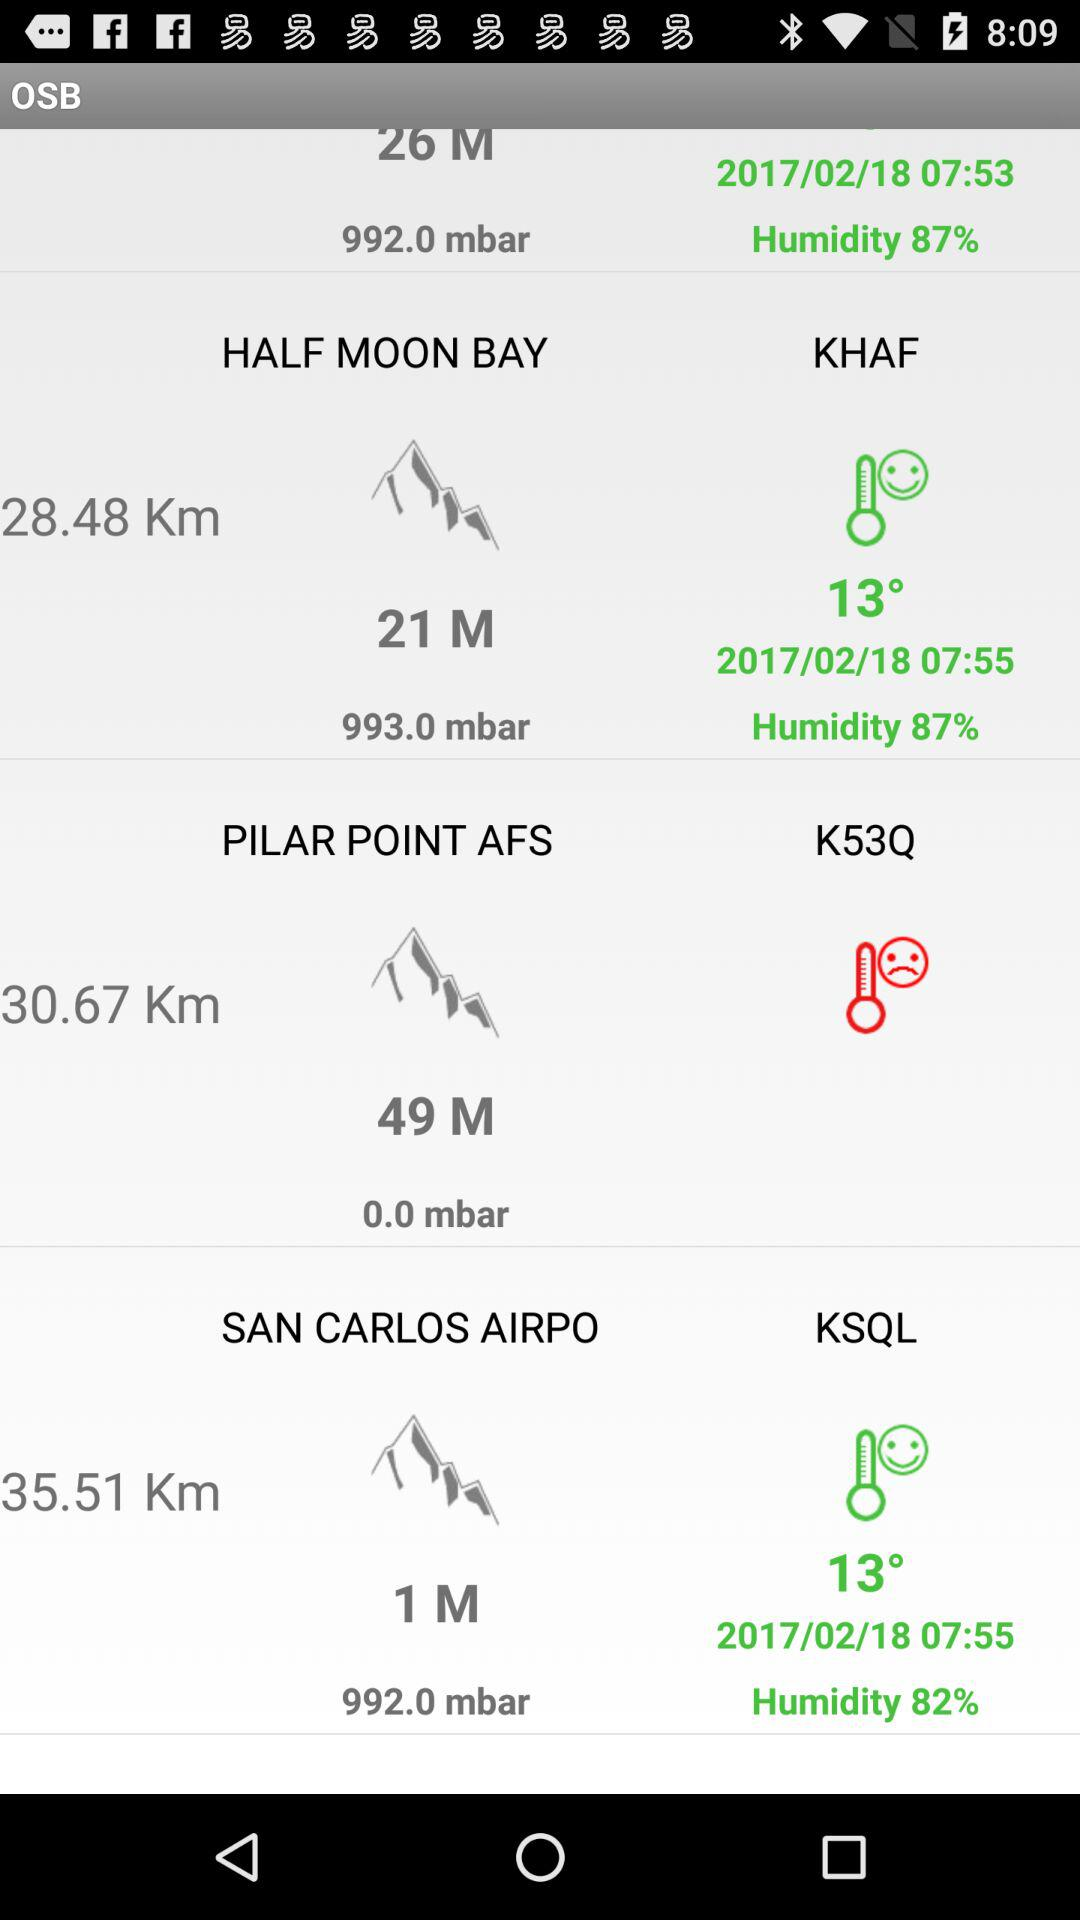What is the distance to San Carlos Airport? The distance to San Carlos Airport is 35.51 km. 